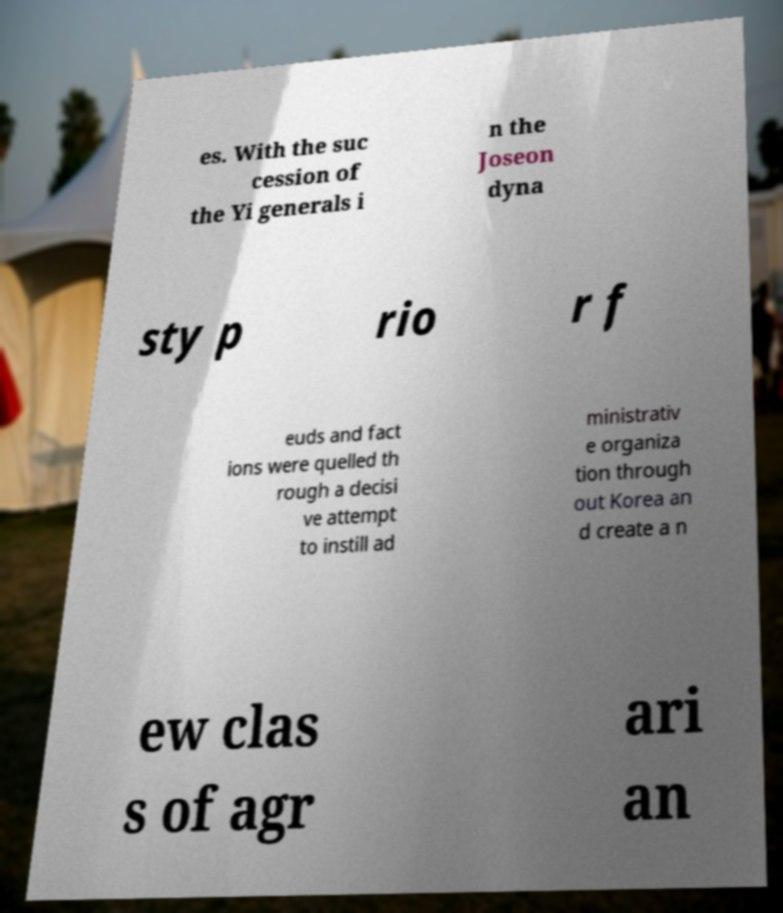Please read and relay the text visible in this image. What does it say? es. With the suc cession of the Yi generals i n the Joseon dyna sty p rio r f euds and fact ions were quelled th rough a decisi ve attempt to instill ad ministrativ e organiza tion through out Korea an d create a n ew clas s of agr ari an 